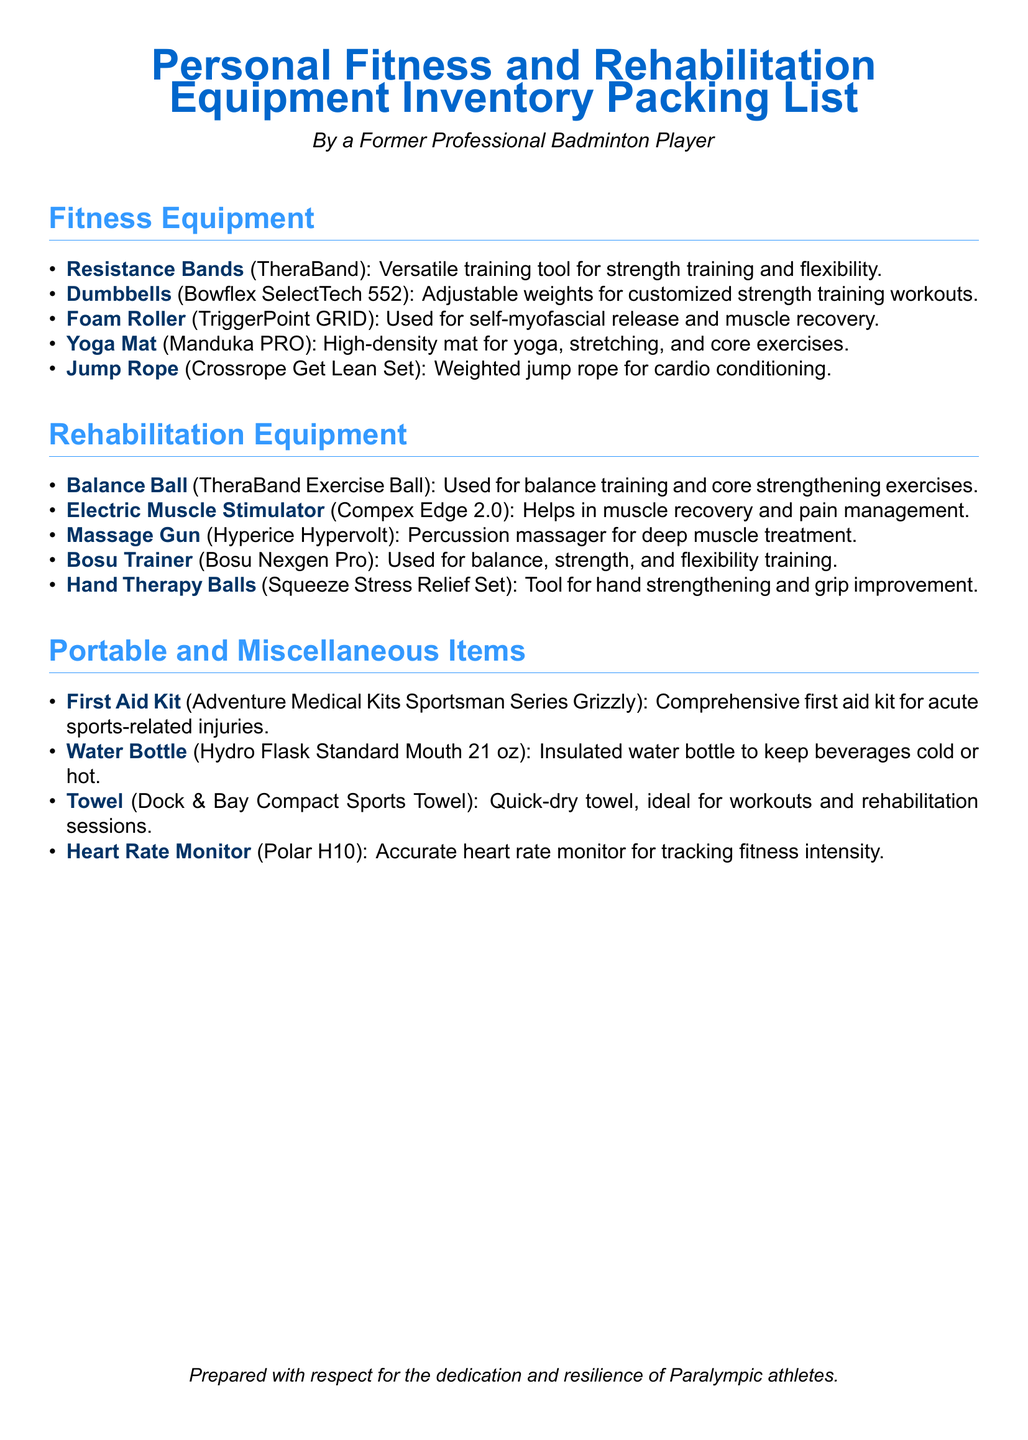What is the name of the adjustable dumbbells listed? The name mentioned is Bowflex SelectTech 552, which is specified under fitness equipment.
Answer: Bowflex SelectTech 552 How many sections are there in the packing list? The document has three main sections: Fitness Equipment, Rehabilitation Equipment, and Portable and Miscellaneous Items.
Answer: Three What is the purpose of the Balance Ball? The Balance Ball is used for balance training and core strengthening exercises, as specified in the document.
Answer: Balance training and core strengthening Which brand is the heart rate monitor from? The document specifies that the heart rate monitor is from Polar, thus indicating its brand.
Answer: Polar What type of towel is included in the miscellaneous items? The towel listed is a quick-dry towel, mentioned as ideal for workouts and rehabilitation sessions.
Answer: Quick-dry towel What equipment is used for self-myofascial release? The Foam Roller, identified as TriggerPoint GRID, is noted for self-myofascial release purposes.
Answer: Foam Roller Which item is meant for deep muscle treatment? The Massage Gun, specifically Hyperice Hypervolt, is designated for deep muscle treatment.
Answer: Massage Gun How many items are listed under the Rehabilitation Equipment section? There are five items listed in the Rehabilitation Equipment section as per the packing list.
Answer: Five 